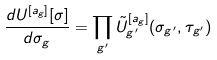Convert formula to latex. <formula><loc_0><loc_0><loc_500><loc_500>\frac { d U ^ { [ a _ { g } ] } [ \sigma ] } { d \sigma _ { g } } = \prod _ { g ^ { \prime } } { \tilde { U } } _ { g ^ { \prime } } ^ { [ a _ { g } ] } ( \sigma _ { g ^ { \prime } } , \tau _ { g ^ { \prime } } )</formula> 